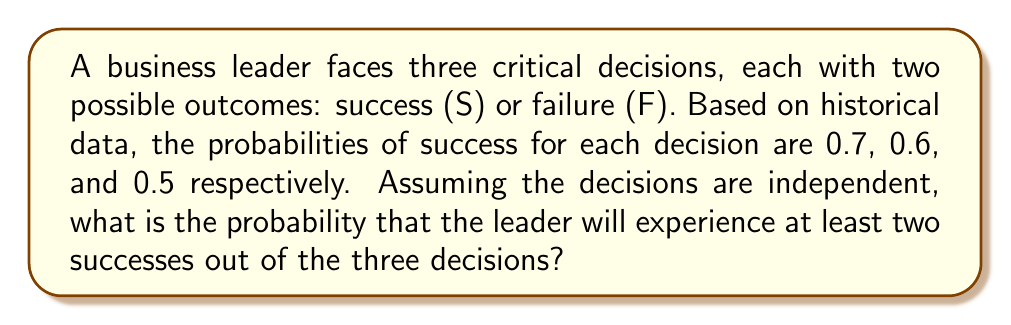Can you answer this question? Let's approach this step-by-step:

1) First, we need to identify the possible scenarios that satisfy our condition (at least two successes):
   - SSS (3 successes)
   - SSF (2 successes, 1 failure)
   - SFS (2 successes, 1 failure)
   - FSS (2 successes, 1 failure)

2) Now, let's calculate the probability of each scenario:

   P(SSS) = 0.7 * 0.6 * 0.5 = 0.21
   P(SSF) = 0.7 * 0.6 * 0.5 = 0.21
   P(SFS) = 0.7 * 0.4 * 0.5 = 0.14
   P(FSS) = 0.3 * 0.6 * 0.5 = 0.09

3) The total probability is the sum of these individual probabilities:

   P(at least 2 successes) = P(SSS) + P(SSF) + P(SFS) + P(FSS)
                           = 0.21 + 0.21 + 0.14 + 0.09
                           = 0.65

4) We can verify this using the complement method:

   P(at least 2 successes) = 1 - P(0 or 1 success)
                           = 1 - [P(FFF) + P(SFF) + P(FSF) + P(FFS)]
                           = 1 - [(0.3*0.4*0.5) + (0.7*0.4*0.5) + (0.3*0.6*0.5) + (0.3*0.4*0.5)]
                           = 1 - [0.06 + 0.14 + 0.09 + 0.06]
                           = 1 - 0.35
                           = 0.65

Therefore, the probability that the leader will experience at least two successes out of the three decisions is 0.65 or 65%.
Answer: 0.65 